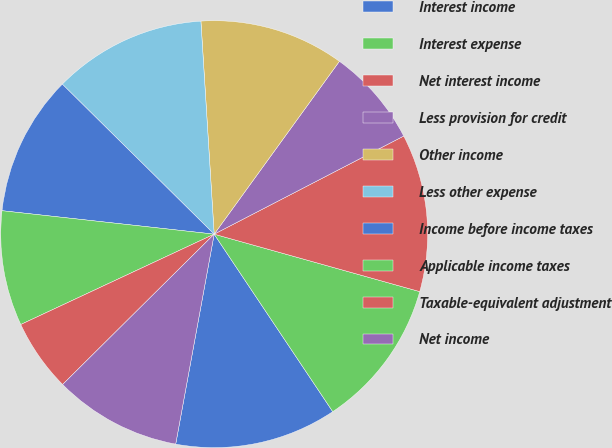Convert chart to OTSL. <chart><loc_0><loc_0><loc_500><loc_500><pie_chart><fcel>Interest income<fcel>Interest expense<fcel>Net interest income<fcel>Less provision for credit<fcel>Other income<fcel>Less other expense<fcel>Income before income taxes<fcel>Applicable income taxes<fcel>Taxable-equivalent adjustment<fcel>Net income<nl><fcel>12.26%<fcel>11.29%<fcel>11.94%<fcel>7.42%<fcel>10.97%<fcel>11.61%<fcel>10.65%<fcel>8.71%<fcel>5.48%<fcel>9.68%<nl></chart> 